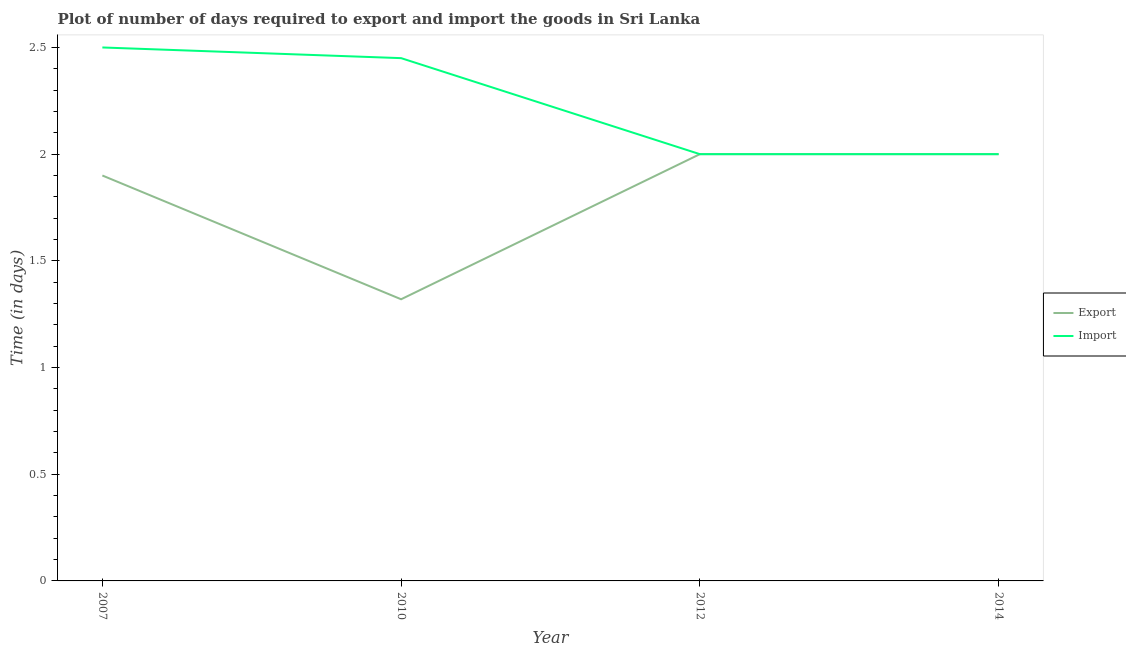How many different coloured lines are there?
Ensure brevity in your answer.  2. Is the number of lines equal to the number of legend labels?
Offer a very short reply. Yes. Across all years, what is the minimum time required to import?
Provide a short and direct response. 2. In which year was the time required to import maximum?
Your answer should be very brief. 2007. What is the total time required to export in the graph?
Ensure brevity in your answer.  7.22. What is the difference between the time required to export in 2007 and that in 2014?
Provide a short and direct response. -0.1. What is the difference between the time required to export in 2014 and the time required to import in 2010?
Make the answer very short. -0.45. What is the average time required to import per year?
Provide a short and direct response. 2.24. In the year 2012, what is the difference between the time required to import and time required to export?
Your answer should be compact. 0. In how many years, is the time required to import greater than 1.9 days?
Offer a very short reply. 4. What is the difference between the highest and the second highest time required to import?
Your response must be concise. 0.05. Is the sum of the time required to import in 2010 and 2014 greater than the maximum time required to export across all years?
Offer a very short reply. Yes. Is the time required to import strictly greater than the time required to export over the years?
Give a very brief answer. No. How many lines are there?
Provide a short and direct response. 2. Are the values on the major ticks of Y-axis written in scientific E-notation?
Offer a terse response. No. Where does the legend appear in the graph?
Your response must be concise. Center right. How many legend labels are there?
Your answer should be very brief. 2. What is the title of the graph?
Keep it short and to the point. Plot of number of days required to export and import the goods in Sri Lanka. Does "Formally registered" appear as one of the legend labels in the graph?
Provide a succinct answer. No. What is the label or title of the Y-axis?
Your answer should be very brief. Time (in days). What is the Time (in days) of Import in 2007?
Provide a short and direct response. 2.5. What is the Time (in days) of Export in 2010?
Your answer should be very brief. 1.32. What is the Time (in days) of Import in 2010?
Offer a terse response. 2.45. What is the Time (in days) of Import in 2012?
Keep it short and to the point. 2. Across all years, what is the maximum Time (in days) of Export?
Offer a very short reply. 2. Across all years, what is the minimum Time (in days) in Export?
Keep it short and to the point. 1.32. What is the total Time (in days) of Export in the graph?
Provide a succinct answer. 7.22. What is the total Time (in days) in Import in the graph?
Offer a very short reply. 8.95. What is the difference between the Time (in days) in Export in 2007 and that in 2010?
Keep it short and to the point. 0.58. What is the difference between the Time (in days) in Import in 2007 and that in 2010?
Your answer should be very brief. 0.05. What is the difference between the Time (in days) in Import in 2007 and that in 2014?
Give a very brief answer. 0.5. What is the difference between the Time (in days) in Export in 2010 and that in 2012?
Provide a short and direct response. -0.68. What is the difference between the Time (in days) of Import in 2010 and that in 2012?
Ensure brevity in your answer.  0.45. What is the difference between the Time (in days) of Export in 2010 and that in 2014?
Keep it short and to the point. -0.68. What is the difference between the Time (in days) of Import in 2010 and that in 2014?
Make the answer very short. 0.45. What is the difference between the Time (in days) in Export in 2012 and that in 2014?
Make the answer very short. 0. What is the difference between the Time (in days) in Import in 2012 and that in 2014?
Your answer should be very brief. 0. What is the difference between the Time (in days) in Export in 2007 and the Time (in days) in Import in 2010?
Make the answer very short. -0.55. What is the difference between the Time (in days) of Export in 2007 and the Time (in days) of Import in 2012?
Keep it short and to the point. -0.1. What is the difference between the Time (in days) of Export in 2007 and the Time (in days) of Import in 2014?
Make the answer very short. -0.1. What is the difference between the Time (in days) of Export in 2010 and the Time (in days) of Import in 2012?
Your response must be concise. -0.68. What is the difference between the Time (in days) of Export in 2010 and the Time (in days) of Import in 2014?
Ensure brevity in your answer.  -0.68. What is the average Time (in days) of Export per year?
Provide a succinct answer. 1.8. What is the average Time (in days) in Import per year?
Provide a succinct answer. 2.24. In the year 2007, what is the difference between the Time (in days) of Export and Time (in days) of Import?
Make the answer very short. -0.6. In the year 2010, what is the difference between the Time (in days) of Export and Time (in days) of Import?
Offer a very short reply. -1.13. In the year 2012, what is the difference between the Time (in days) of Export and Time (in days) of Import?
Your answer should be very brief. 0. What is the ratio of the Time (in days) in Export in 2007 to that in 2010?
Your answer should be very brief. 1.44. What is the ratio of the Time (in days) of Import in 2007 to that in 2010?
Give a very brief answer. 1.02. What is the ratio of the Time (in days) in Import in 2007 to that in 2012?
Provide a short and direct response. 1.25. What is the ratio of the Time (in days) in Export in 2010 to that in 2012?
Offer a terse response. 0.66. What is the ratio of the Time (in days) of Import in 2010 to that in 2012?
Ensure brevity in your answer.  1.23. What is the ratio of the Time (in days) in Export in 2010 to that in 2014?
Your response must be concise. 0.66. What is the ratio of the Time (in days) of Import in 2010 to that in 2014?
Your answer should be very brief. 1.23. What is the ratio of the Time (in days) in Import in 2012 to that in 2014?
Offer a terse response. 1. What is the difference between the highest and the second highest Time (in days) in Export?
Your answer should be very brief. 0. What is the difference between the highest and the second highest Time (in days) of Import?
Provide a short and direct response. 0.05. What is the difference between the highest and the lowest Time (in days) in Export?
Your answer should be compact. 0.68. 